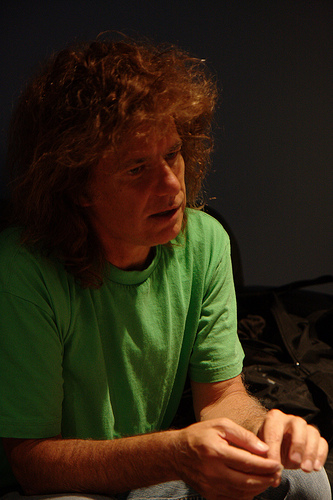<image>
Can you confirm if the bed is on the man? No. The bed is not positioned on the man. They may be near each other, but the bed is not supported by or resting on top of the man. 